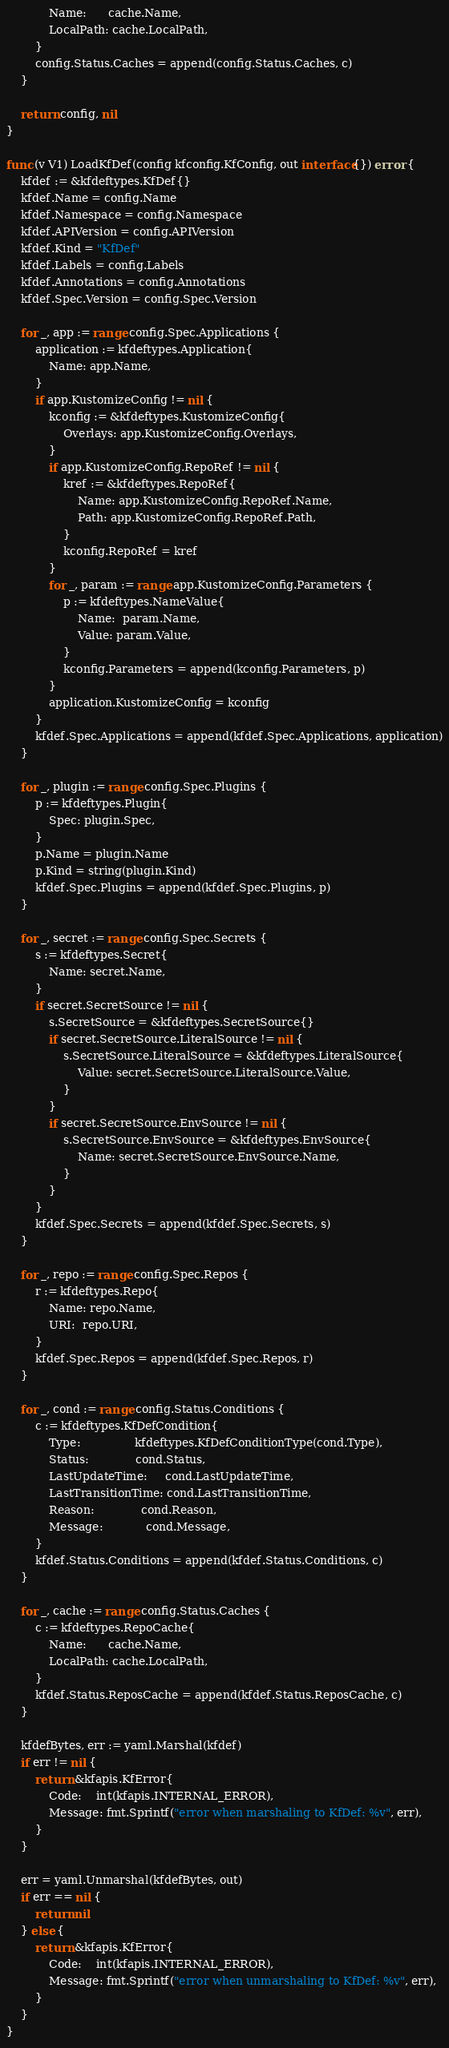Convert code to text. <code><loc_0><loc_0><loc_500><loc_500><_Go_>			Name:      cache.Name,
			LocalPath: cache.LocalPath,
		}
		config.Status.Caches = append(config.Status.Caches, c)
	}

	return config, nil
}

func (v V1) LoadKfDef(config kfconfig.KfConfig, out interface{}) error {
	kfdef := &kfdeftypes.KfDef{}
	kfdef.Name = config.Name
	kfdef.Namespace = config.Namespace
	kfdef.APIVersion = config.APIVersion
	kfdef.Kind = "KfDef"
	kfdef.Labels = config.Labels
	kfdef.Annotations = config.Annotations
	kfdef.Spec.Version = config.Spec.Version

	for _, app := range config.Spec.Applications {
		application := kfdeftypes.Application{
			Name: app.Name,
		}
		if app.KustomizeConfig != nil {
			kconfig := &kfdeftypes.KustomizeConfig{
				Overlays: app.KustomizeConfig.Overlays,
			}
			if app.KustomizeConfig.RepoRef != nil {
				kref := &kfdeftypes.RepoRef{
					Name: app.KustomizeConfig.RepoRef.Name,
					Path: app.KustomizeConfig.RepoRef.Path,
				}
				kconfig.RepoRef = kref
			}
			for _, param := range app.KustomizeConfig.Parameters {
				p := kfdeftypes.NameValue{
					Name:  param.Name,
					Value: param.Value,
				}
				kconfig.Parameters = append(kconfig.Parameters, p)
			}
			application.KustomizeConfig = kconfig
		}
		kfdef.Spec.Applications = append(kfdef.Spec.Applications, application)
	}

	for _, plugin := range config.Spec.Plugins {
		p := kfdeftypes.Plugin{
			Spec: plugin.Spec,
		}
		p.Name = plugin.Name
		p.Kind = string(plugin.Kind)
		kfdef.Spec.Plugins = append(kfdef.Spec.Plugins, p)
	}

	for _, secret := range config.Spec.Secrets {
		s := kfdeftypes.Secret{
			Name: secret.Name,
		}
		if secret.SecretSource != nil {
			s.SecretSource = &kfdeftypes.SecretSource{}
			if secret.SecretSource.LiteralSource != nil {
				s.SecretSource.LiteralSource = &kfdeftypes.LiteralSource{
					Value: secret.SecretSource.LiteralSource.Value,
				}
			}
			if secret.SecretSource.EnvSource != nil {
				s.SecretSource.EnvSource = &kfdeftypes.EnvSource{
					Name: secret.SecretSource.EnvSource.Name,
				}
			}
		}
		kfdef.Spec.Secrets = append(kfdef.Spec.Secrets, s)
	}

	for _, repo := range config.Spec.Repos {
		r := kfdeftypes.Repo{
			Name: repo.Name,
			URI:  repo.URI,
		}
		kfdef.Spec.Repos = append(kfdef.Spec.Repos, r)
	}

	for _, cond := range config.Status.Conditions {
		c := kfdeftypes.KfDefCondition{
			Type:               kfdeftypes.KfDefConditionType(cond.Type),
			Status:             cond.Status,
			LastUpdateTime:     cond.LastUpdateTime,
			LastTransitionTime: cond.LastTransitionTime,
			Reason:             cond.Reason,
			Message:            cond.Message,
		}
		kfdef.Status.Conditions = append(kfdef.Status.Conditions, c)
	}

	for _, cache := range config.Status.Caches {
		c := kfdeftypes.RepoCache{
			Name:      cache.Name,
			LocalPath: cache.LocalPath,
		}
		kfdef.Status.ReposCache = append(kfdef.Status.ReposCache, c)
	}

	kfdefBytes, err := yaml.Marshal(kfdef)
	if err != nil {
		return &kfapis.KfError{
			Code:    int(kfapis.INTERNAL_ERROR),
			Message: fmt.Sprintf("error when marshaling to KfDef: %v", err),
		}
	}

	err = yaml.Unmarshal(kfdefBytes, out)
	if err == nil {
		return nil
	} else {
		return &kfapis.KfError{
			Code:    int(kfapis.INTERNAL_ERROR),
			Message: fmt.Sprintf("error when unmarshaling to KfDef: %v", err),
		}
	}
}
</code> 